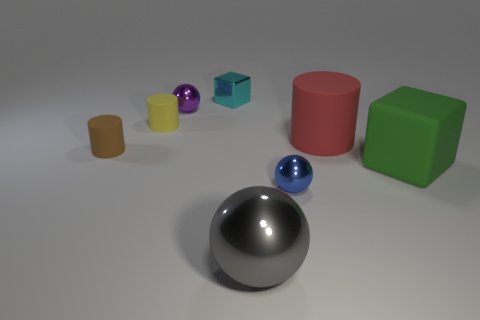What material is the large red cylinder behind the tiny metallic object right of the cyan metal thing made of?
Give a very brief answer. Rubber. There is a green cube that is the same material as the large red cylinder; what size is it?
Provide a succinct answer. Large. There is a red matte object that is the same shape as the brown rubber thing; what is its size?
Ensure brevity in your answer.  Large. There is a cylinder to the right of the small purple metal sphere; what is it made of?
Your answer should be very brief. Rubber. There is a rubber cylinder that is to the right of the purple shiny thing; is its size the same as the cyan metallic block?
Give a very brief answer. No. What is the material of the blue ball?
Provide a succinct answer. Metal. The cylinder that is both to the right of the brown matte cylinder and to the left of the large gray object is made of what material?
Your answer should be compact. Rubber. What number of things are rubber things that are left of the purple ball or large red blocks?
Your response must be concise. 2. Are there any purple metal balls of the same size as the gray object?
Provide a short and direct response. No. How many balls are both in front of the tiny brown cylinder and behind the small brown rubber object?
Provide a short and direct response. 0. 